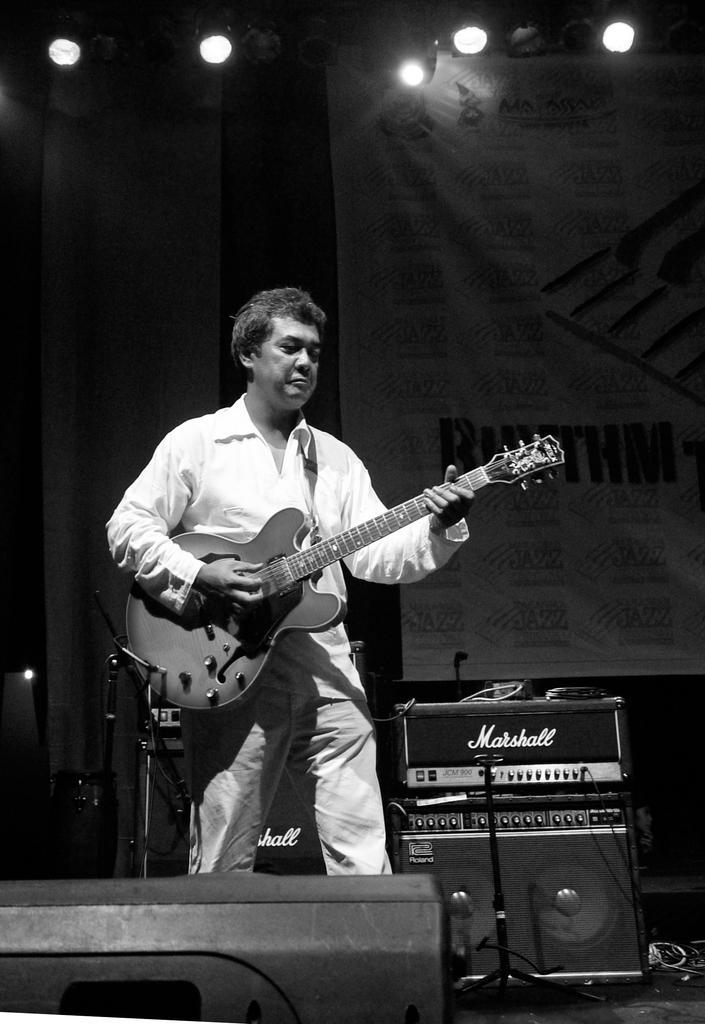Can you describe this image briefly? In this image, in the middle there is a man standing and he is holding a music instrument which is in black color, in the right side there are some music instruments which are in black color kept on the ground, in the top there are some lights which are in white color, in the background there is a white color poster. 